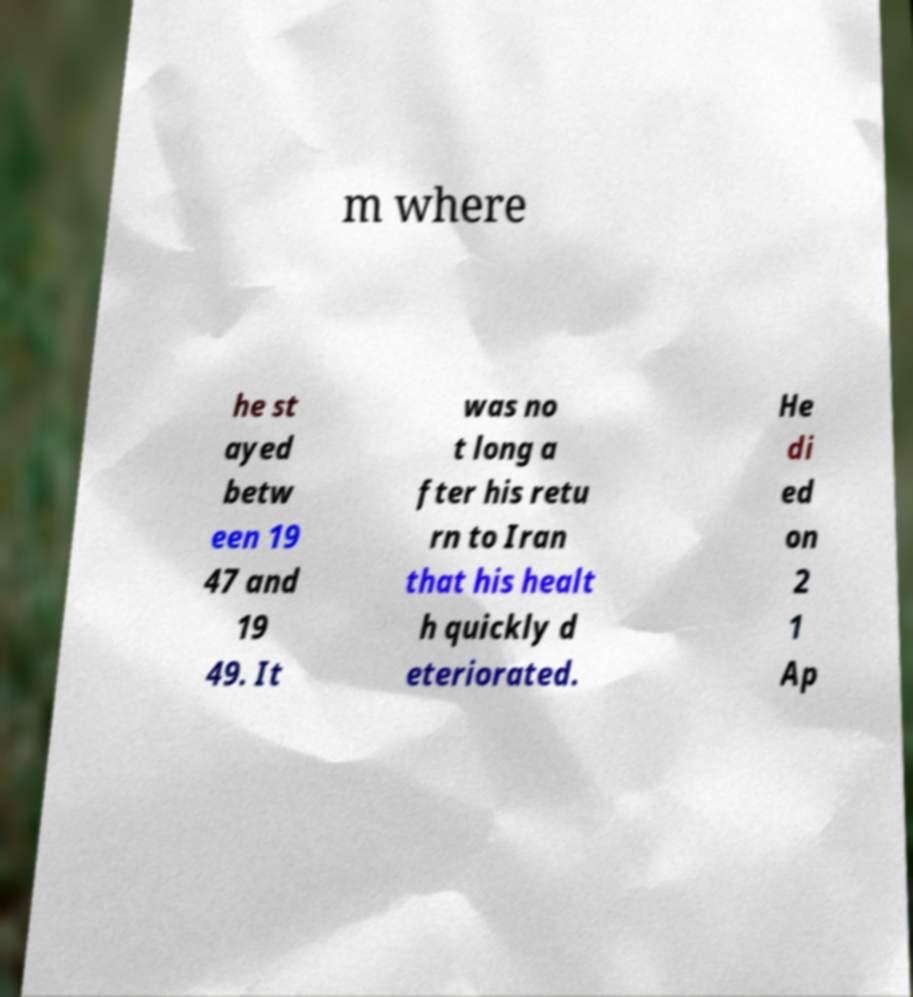Please read and relay the text visible in this image. What does it say? m where he st ayed betw een 19 47 and 19 49. It was no t long a fter his retu rn to Iran that his healt h quickly d eteriorated. He di ed on 2 1 Ap 